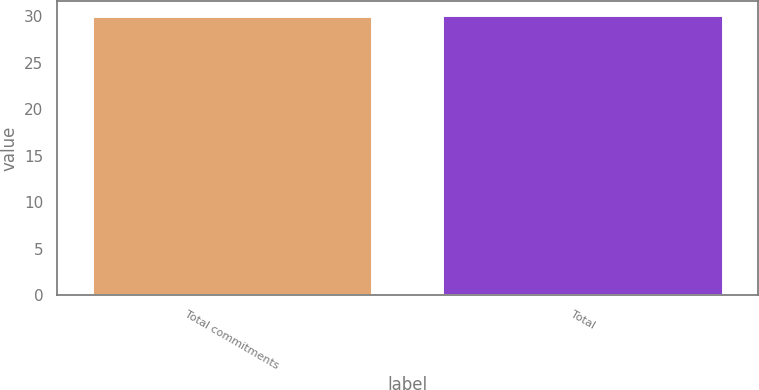Convert chart to OTSL. <chart><loc_0><loc_0><loc_500><loc_500><bar_chart><fcel>Total commitments<fcel>Total<nl><fcel>30<fcel>30.1<nl></chart> 